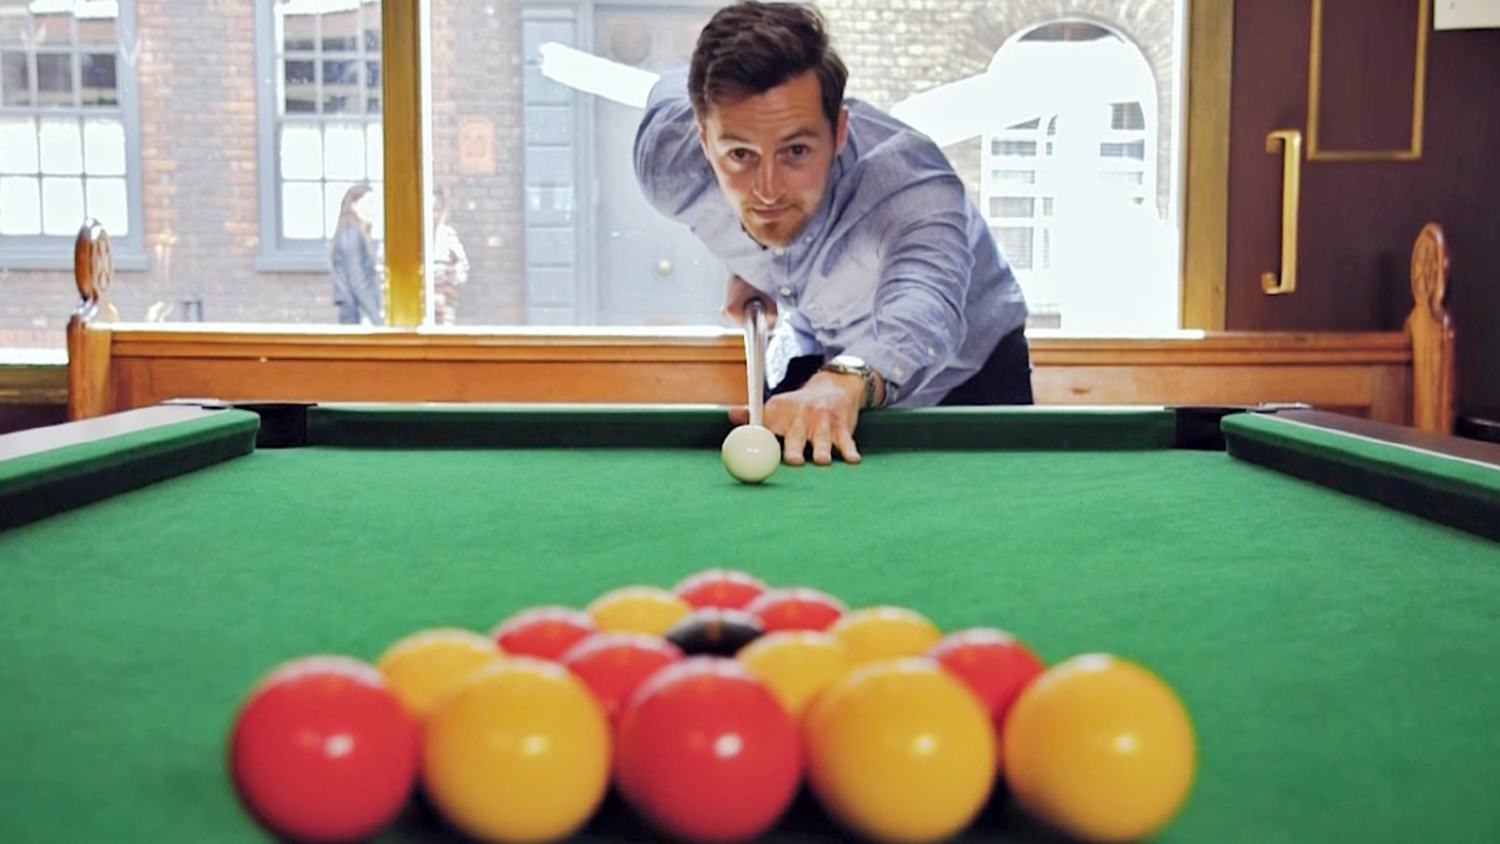The man seems very focused. What could be going through his mind at this moment? At this moment, the man is likely intensely focused on the shot he is about to make. He is probably considering multiple factors such as the angle of his shot, the speed at which he needs to hit the cue ball, any potential obstacles, and the overall strategy for the game. He might be visualizing the path the cue ball will take and which balls it needs to hit in sequence. His mind is also likely clear of distractions, tuned into the minute details that will affect the shot's success. The tension and excitement of executing the perfect shot could also be a significant part of his thought process. How effective do you think his shot will be based on his current posture and focus? Given his current posture and focus, his shot is likely to be quite effective. His stance suggests a solid understanding of pool dynamics, with a stable bridge hand and cue alignment that indicate proper form. His intense focus implies he is mentally calculating the shot with precision. However, the effectiveness of his shot ultimately depends on his execution; if he maintains this posture and concentration, he stands a good chance of making a successful shot. 